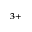Convert formula to latex. <formula><loc_0><loc_0><loc_500><loc_500>^ { 3 + }</formula> 